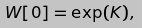Convert formula to latex. <formula><loc_0><loc_0><loc_500><loc_500>W [ 0 ] = \exp ( K ) ,</formula> 